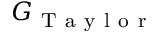<formula> <loc_0><loc_0><loc_500><loc_500>G _ { T a y l o r }</formula> 